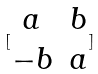Convert formula to latex. <formula><loc_0><loc_0><loc_500><loc_500>[ \begin{matrix} a & b \\ - b & a \end{matrix} ]</formula> 